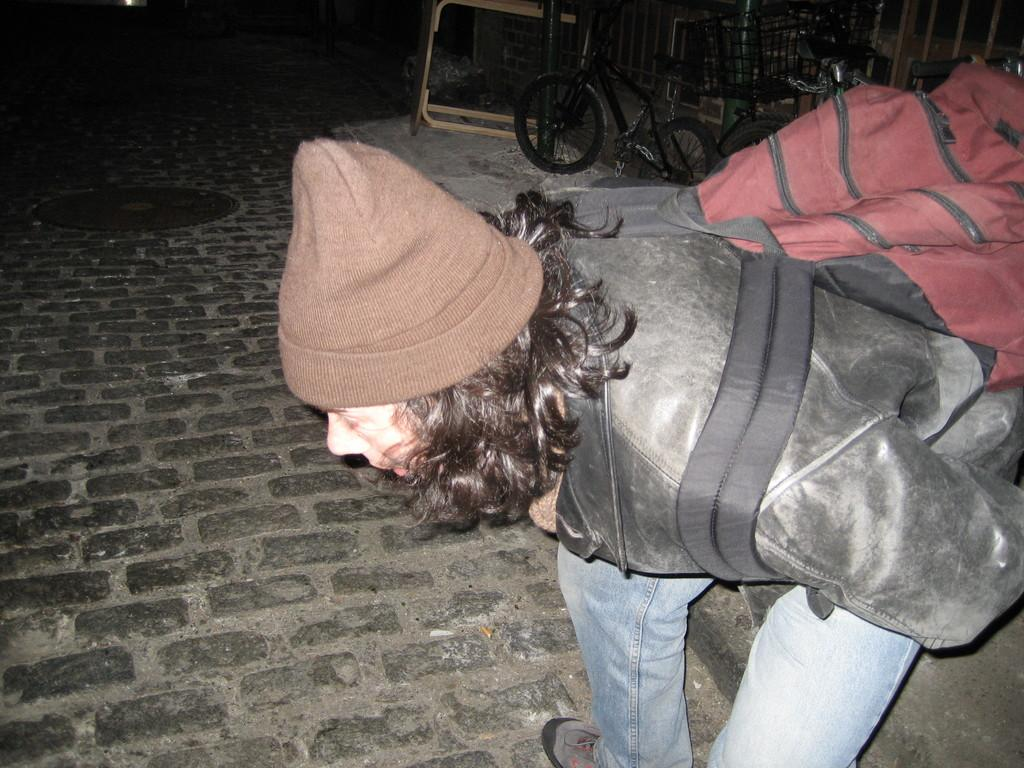What is the main subject of the image? There is a person in the image. What is the person doing in the image? The person is bending. What is the person carrying on his back? The person is carrying a backpack on his back. What can be seen on the right side of the person? There is a bicycle parked on the right side of the person. What type of quill is the person using to write on the bicycle in the image? There is no quill present in the image, and the person is not writing on the bicycle. 